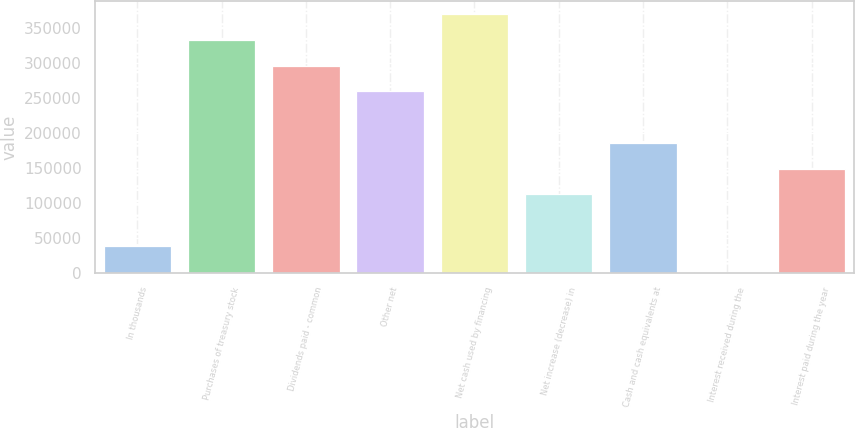Convert chart. <chart><loc_0><loc_0><loc_500><loc_500><bar_chart><fcel>In thousands<fcel>Purchases of treasury stock<fcel>Dividends paid - common<fcel>Other net<fcel>Net cash used by financing<fcel>Net increase (decrease) in<fcel>Cash and cash equivalents at<fcel>Interest received during the<fcel>Interest paid during the year<nl><fcel>38600.5<fcel>333588<fcel>296715<fcel>259842<fcel>370462<fcel>112348<fcel>186094<fcel>1727<fcel>149221<nl></chart> 